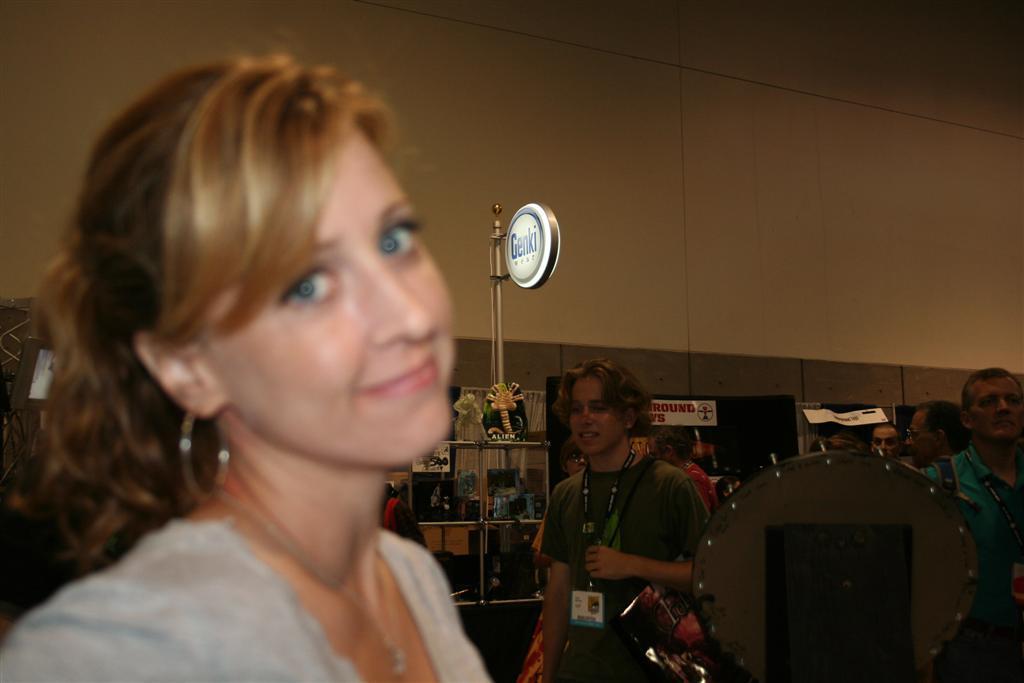Can you describe this image briefly? In this image, we can see a lady standing and in the background, there are people wearing id cards and we can see boards, banners, papers and some objects in the racks and there is wall. 